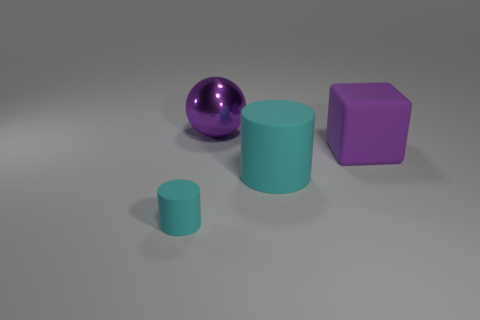There is a large matte object that is the same color as the large metal ball; what shape is it?
Provide a short and direct response. Cube. How many cyan rubber cylinders are to the left of the big thing that is to the left of the cyan cylinder on the right side of the large purple metal sphere?
Keep it short and to the point. 1. What color is the metallic ball that is the same size as the purple matte cube?
Keep it short and to the point. Purple. There is a matte cylinder that is behind the thing on the left side of the ball; what is its size?
Offer a terse response. Large. What size is the other rubber cylinder that is the same color as the small rubber cylinder?
Give a very brief answer. Large. How many other objects are there of the same size as the metallic ball?
Offer a terse response. 2. What number of large purple things are there?
Keep it short and to the point. 2. Does the sphere have the same size as the purple rubber thing?
Give a very brief answer. Yes. How many other things are there of the same shape as the tiny cyan rubber object?
Offer a very short reply. 1. What is the thing in front of the cylinder that is to the right of the large metallic sphere made of?
Keep it short and to the point. Rubber. 